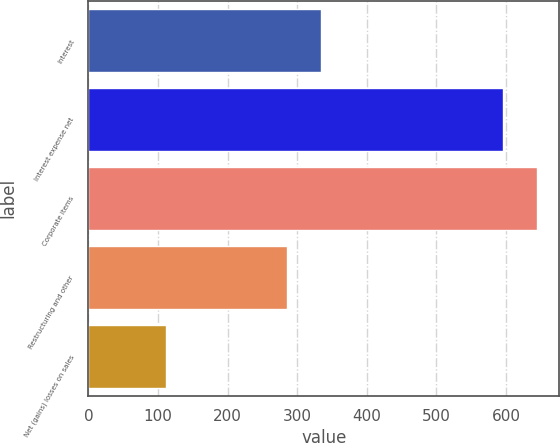Convert chart to OTSL. <chart><loc_0><loc_0><loc_500><loc_500><bar_chart><fcel>Interest<fcel>Interest expense net<fcel>Corporate items<fcel>Restructuring and other<fcel>Net (gains) losses on sales<nl><fcel>334.6<fcel>595<fcel>644.6<fcel>285<fcel>111<nl></chart> 